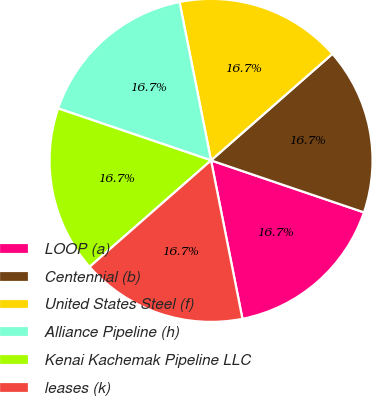<chart> <loc_0><loc_0><loc_500><loc_500><pie_chart><fcel>LOOP (a)<fcel>Centennial (b)<fcel>United States Steel (f)<fcel>Alliance Pipeline (h)<fcel>Kenai Kachemak Pipeline LLC<fcel>leases (k)<nl><fcel>16.67%<fcel>16.68%<fcel>16.66%<fcel>16.66%<fcel>16.67%<fcel>16.66%<nl></chart> 